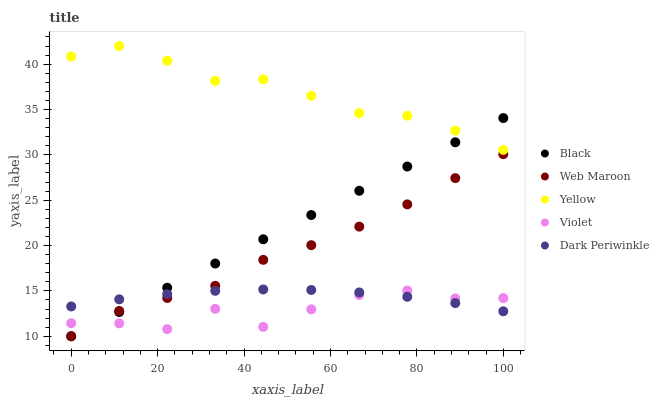Does Violet have the minimum area under the curve?
Answer yes or no. Yes. Does Yellow have the maximum area under the curve?
Answer yes or no. Yes. Does Black have the minimum area under the curve?
Answer yes or no. No. Does Black have the maximum area under the curve?
Answer yes or no. No. Is Black the smoothest?
Answer yes or no. Yes. Is Violet the roughest?
Answer yes or no. Yes. Is Dark Periwinkle the smoothest?
Answer yes or no. No. Is Dark Periwinkle the roughest?
Answer yes or no. No. Does Web Maroon have the lowest value?
Answer yes or no. Yes. Does Dark Periwinkle have the lowest value?
Answer yes or no. No. Does Yellow have the highest value?
Answer yes or no. Yes. Does Black have the highest value?
Answer yes or no. No. Is Violet less than Yellow?
Answer yes or no. Yes. Is Yellow greater than Violet?
Answer yes or no. Yes. Does Black intersect Yellow?
Answer yes or no. Yes. Is Black less than Yellow?
Answer yes or no. No. Is Black greater than Yellow?
Answer yes or no. No. Does Violet intersect Yellow?
Answer yes or no. No. 